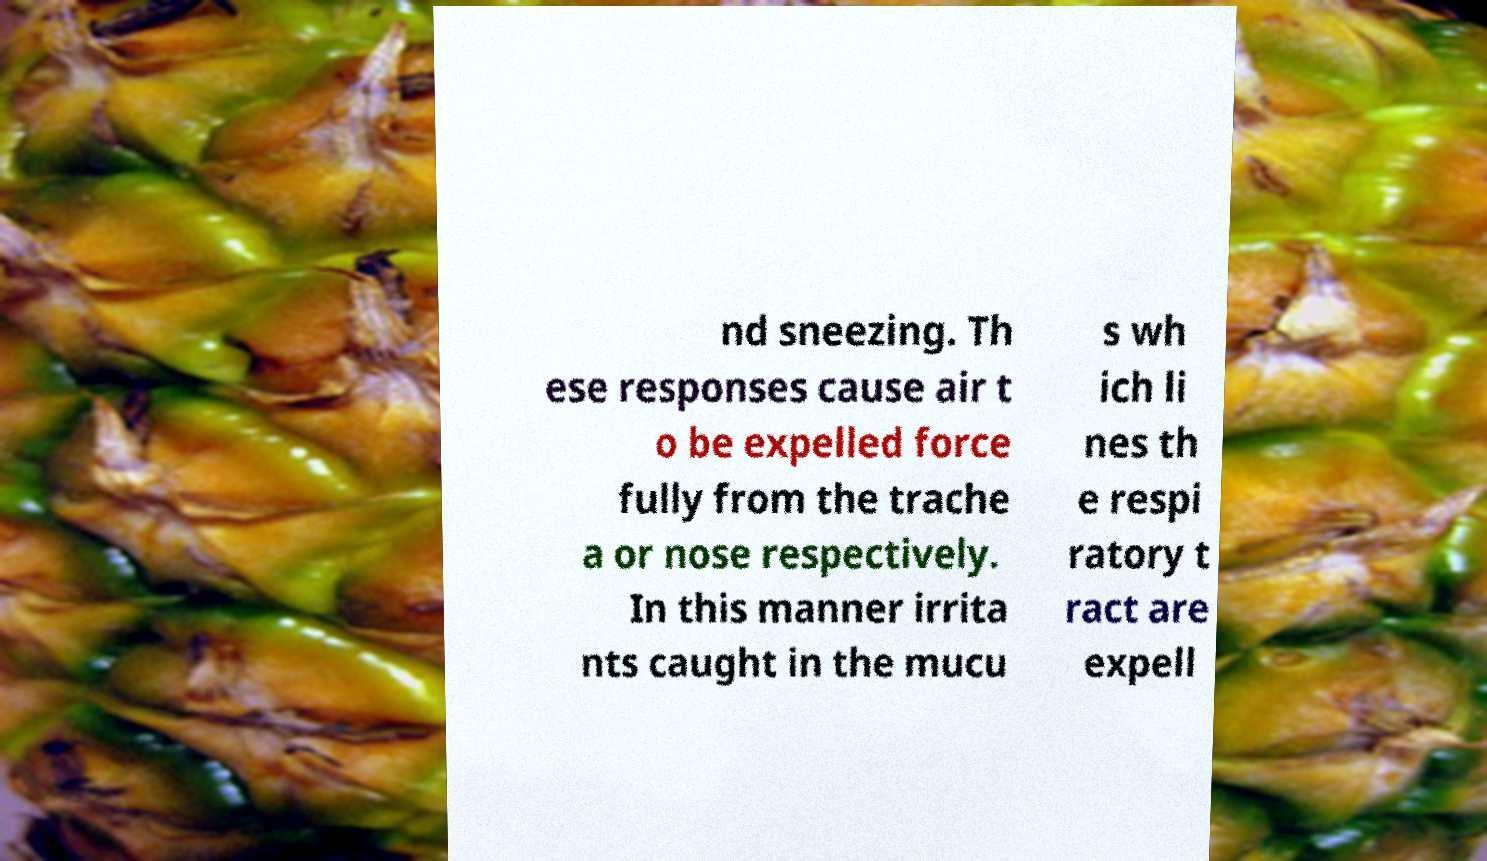Please read and relay the text visible in this image. What does it say? nd sneezing. Th ese responses cause air t o be expelled force fully from the trache a or nose respectively. In this manner irrita nts caught in the mucu s wh ich li nes th e respi ratory t ract are expell 